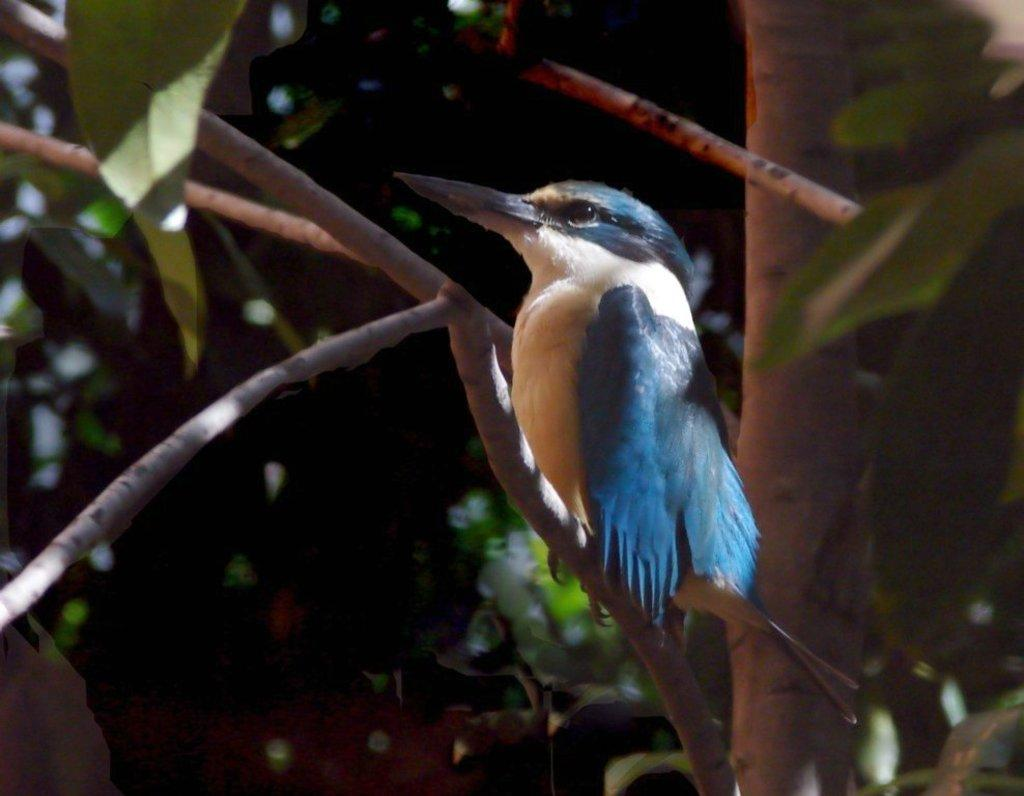What is on the tree in the image? There is a bird on a tree in the image. Can you describe the bird's appearance? The bird is blue and white in color. What can be seen in the background of the image? There are trees in the background of the image. What type of rhythm does the bird's skirt have in the image? There is no mention of a skirt or rhythm in the image; it features a bird on a tree. 